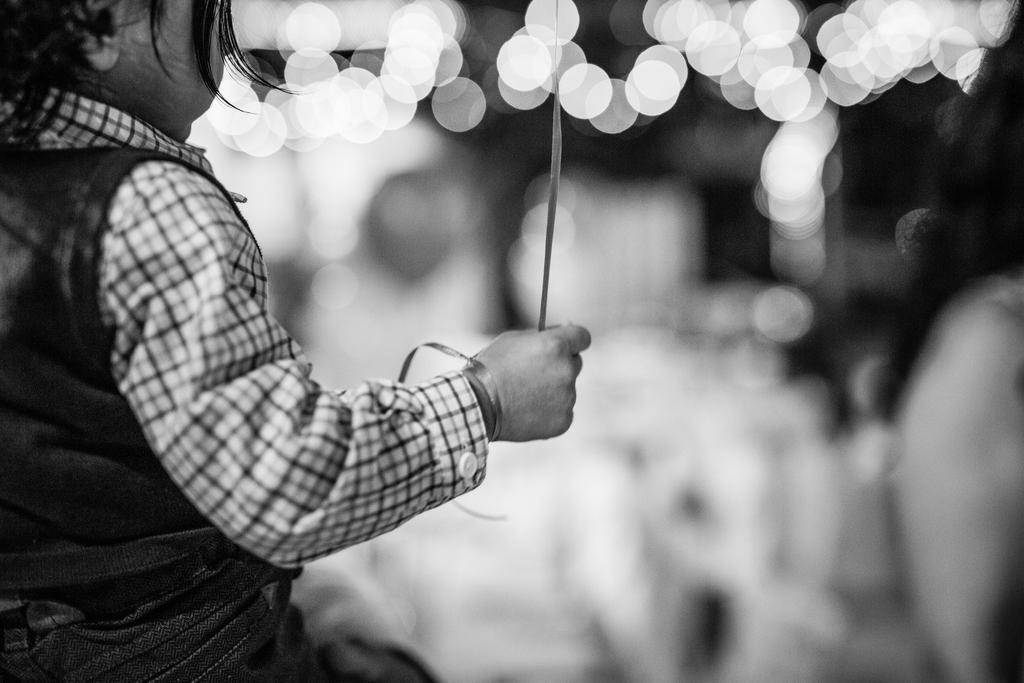Could you give a brief overview of what you see in this image? It is looking like a black and white picture. We can see a kid is holding an item and behind the kid there is a blurred background. 